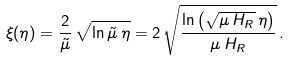Convert formula to latex. <formula><loc_0><loc_0><loc_500><loc_500>\xi ( \eta ) = \frac { 2 } { \tilde { \mu } } \, \sqrt { \ln { \tilde { \mu } } \, \eta } = 2 \, \sqrt { \frac { \ln \left ( \sqrt { \mu \, H _ { R } } \, \eta \right ) } { \mu \, H _ { R } } } \, .</formula> 